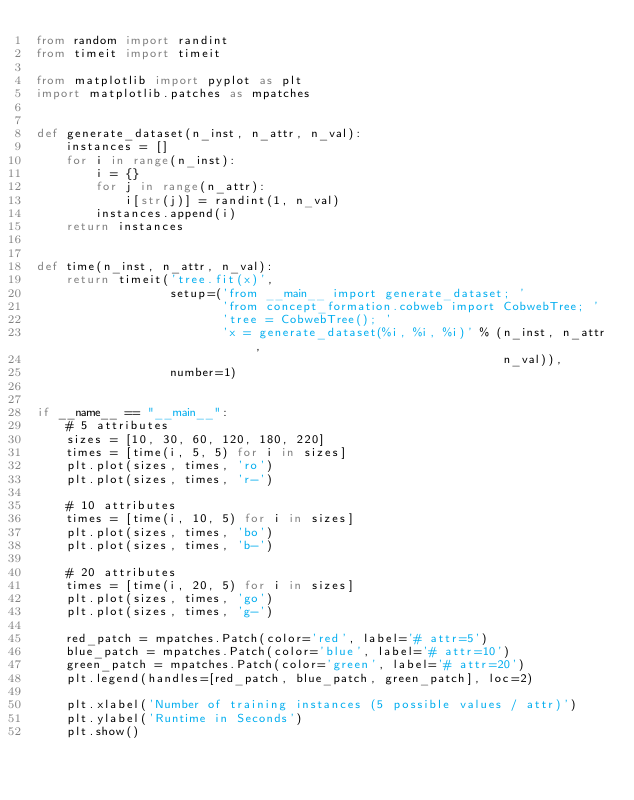<code> <loc_0><loc_0><loc_500><loc_500><_Python_>from random import randint
from timeit import timeit

from matplotlib import pyplot as plt
import matplotlib.patches as mpatches


def generate_dataset(n_inst, n_attr, n_val):
    instances = []
    for i in range(n_inst):
        i = {}
        for j in range(n_attr):
            i[str(j)] = randint(1, n_val)
        instances.append(i)
    return instances


def time(n_inst, n_attr, n_val):
    return timeit('tree.fit(x)',
                  setup=('from __main__ import generate_dataset; '
                         'from concept_formation.cobweb import CobwebTree; '
                         'tree = CobwebTree(); '
                         'x = generate_dataset(%i, %i, %i)' % (n_inst, n_attr,
                                                               n_val)),
                  number=1)


if __name__ == "__main__":
    # 5 attributes
    sizes = [10, 30, 60, 120, 180, 220]
    times = [time(i, 5, 5) for i in sizes]
    plt.plot(sizes, times, 'ro')
    plt.plot(sizes, times, 'r-')

    # 10 attributes
    times = [time(i, 10, 5) for i in sizes]
    plt.plot(sizes, times, 'bo')
    plt.plot(sizes, times, 'b-')

    # 20 attributes
    times = [time(i, 20, 5) for i in sizes]
    plt.plot(sizes, times, 'go')
    plt.plot(sizes, times, 'g-')

    red_patch = mpatches.Patch(color='red', label='# attr=5')
    blue_patch = mpatches.Patch(color='blue', label='# attr=10')
    green_patch = mpatches.Patch(color='green', label='# attr=20')
    plt.legend(handles=[red_patch, blue_patch, green_patch], loc=2)

    plt.xlabel('Number of training instances (5 possible values / attr)')
    plt.ylabel('Runtime in Seconds')
    plt.show()
</code> 